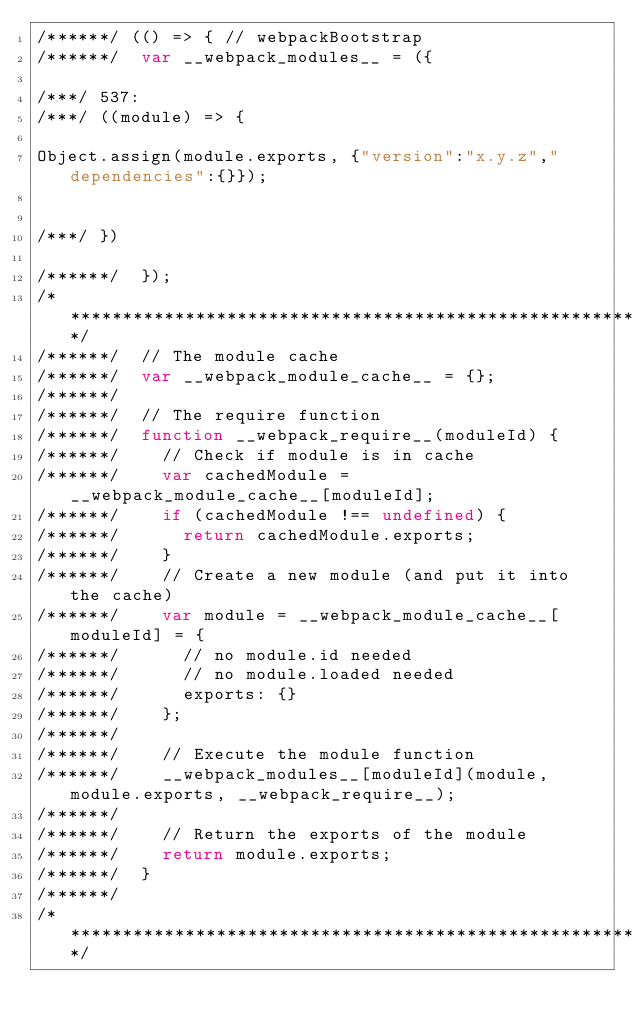Convert code to text. <code><loc_0><loc_0><loc_500><loc_500><_JavaScript_>/******/ (() => { // webpackBootstrap
/******/ 	var __webpack_modules__ = ({

/***/ 537:
/***/ ((module) => {

Object.assign(module.exports, {"version":"x.y.z","dependencies":{}});


/***/ })

/******/ 	});
/************************************************************************/
/******/ 	// The module cache
/******/ 	var __webpack_module_cache__ = {};
/******/ 	
/******/ 	// The require function
/******/ 	function __webpack_require__(moduleId) {
/******/ 		// Check if module is in cache
/******/ 		var cachedModule = __webpack_module_cache__[moduleId];
/******/ 		if (cachedModule !== undefined) {
/******/ 			return cachedModule.exports;
/******/ 		}
/******/ 		// Create a new module (and put it into the cache)
/******/ 		var module = __webpack_module_cache__[moduleId] = {
/******/ 			// no module.id needed
/******/ 			// no module.loaded needed
/******/ 			exports: {}
/******/ 		};
/******/ 	
/******/ 		// Execute the module function
/******/ 		__webpack_modules__[moduleId](module, module.exports, __webpack_require__);
/******/ 	
/******/ 		// Return the exports of the module
/******/ 		return module.exports;
/******/ 	}
/******/ 	
/************************************************************************/</code> 